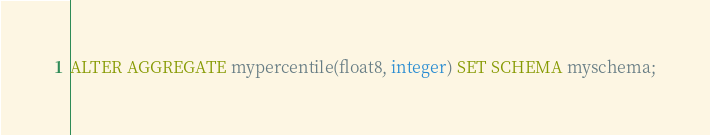<code> <loc_0><loc_0><loc_500><loc_500><_SQL_>ALTER AGGREGATE mypercentile(float8, integer) SET SCHEMA myschema;
</code> 